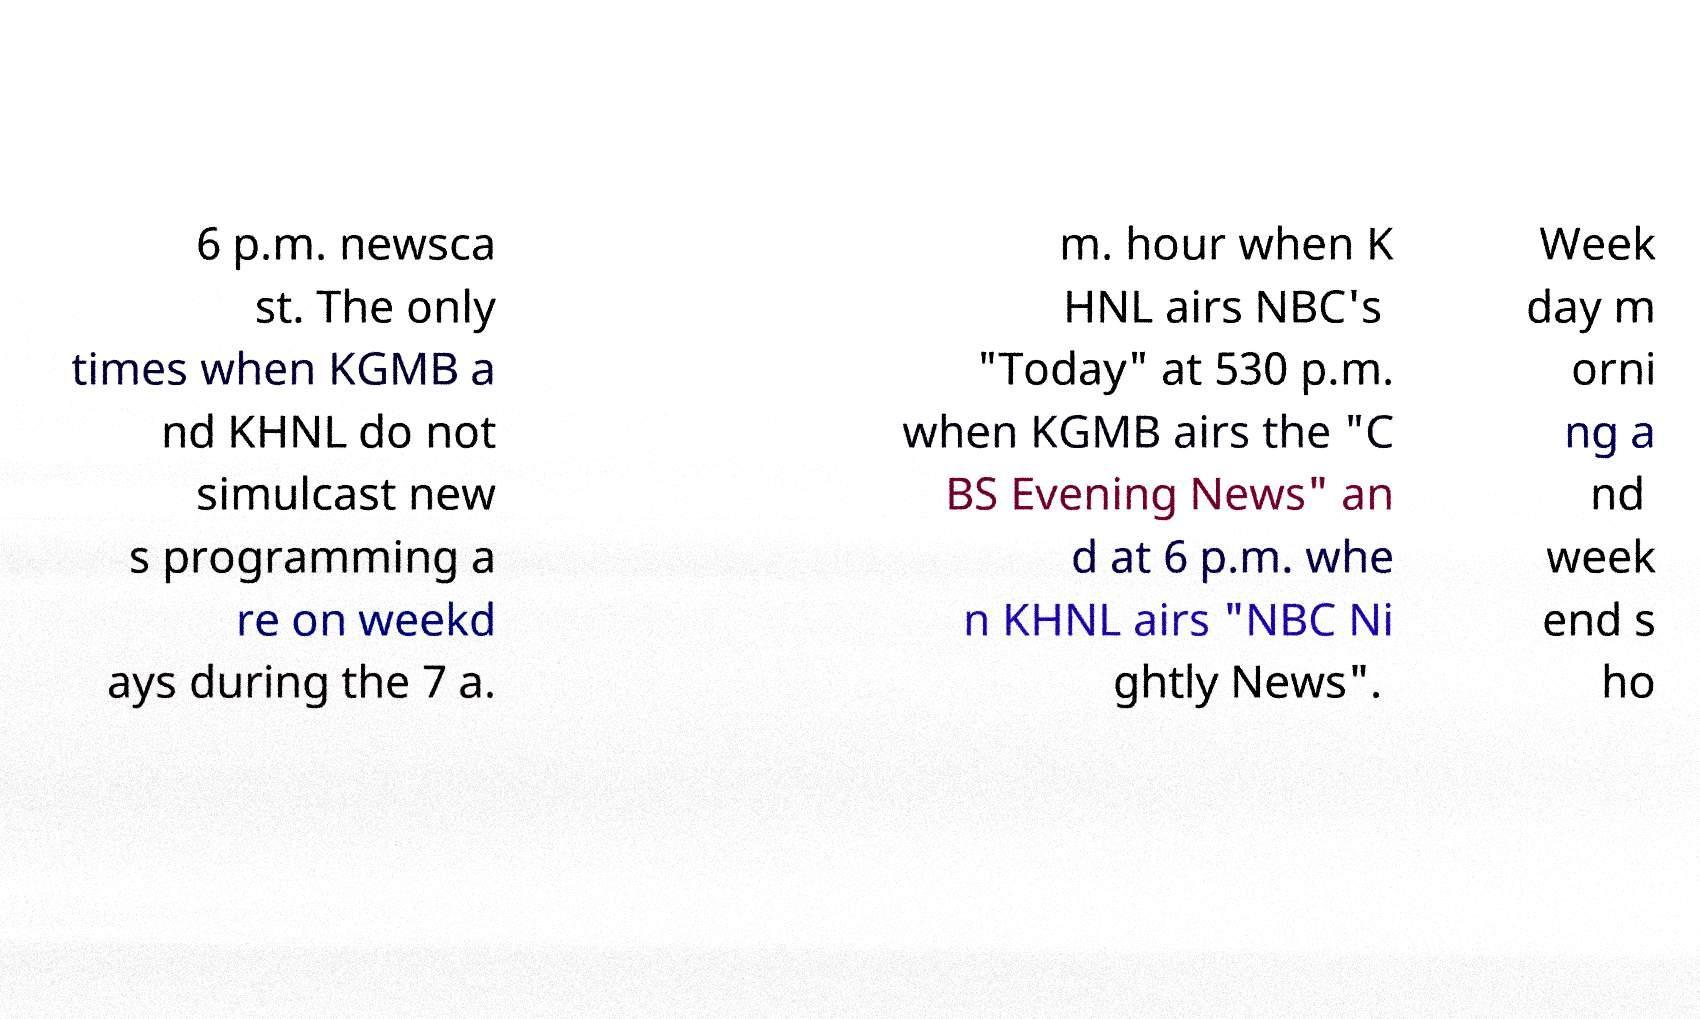I need the written content from this picture converted into text. Can you do that? 6 p.m. newsca st. The only times when KGMB a nd KHNL do not simulcast new s programming a re on weekd ays during the 7 a. m. hour when K HNL airs NBC's "Today" at 530 p.m. when KGMB airs the "C BS Evening News" an d at 6 p.m. whe n KHNL airs "NBC Ni ghtly News". Week day m orni ng a nd week end s ho 